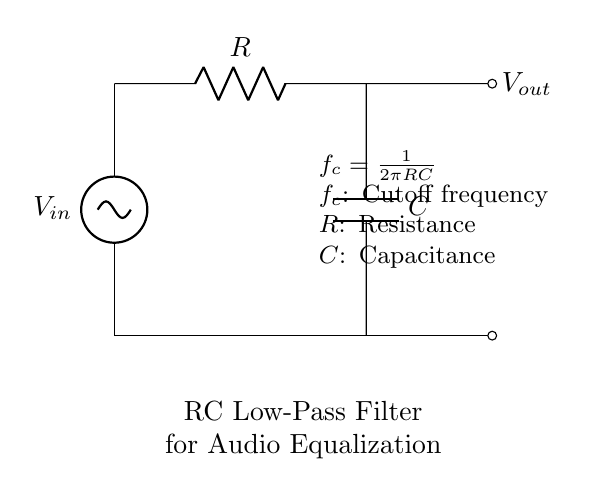What is the input voltage of this circuit? The input voltage is represented by the symbol V_in, which is located at the top of the circuit diagram.
Answer: V_in What components are present in this RC filter? The components in the circuit are a resistor and a capacitor, which are labeled as R and C, respectively.
Answer: Resistor and Capacitor What is the function of this RC circuit? The RC circuit functions as a low-pass filter, indicated by the description provided in the diagram. Low-pass filters allow low-frequency signals to pass while attenuating higher frequencies.
Answer: Low-pass filter What is the cutoff frequency formula for this circuit? The cutoff frequency formula is given as f_c = 1 / (2πRC) in the diagram. This equation describes how the cutoff frequency is determined based on the resistance (R) and capacitance (C) values.
Answer: f_c = 1 / (2πRC) If R is doubled while C remains the same, how does the cutoff frequency change? If R is doubled, the cutoff frequency f_c will decrease because it is inversely proportional to R in the formula f_c = 1 / (2πRC). Thus, increasing R would lead to a lower cutoff frequency. The calculation shows that a higher R leads to a smaller f_c.
Answer: Decreases What happens to the output voltage when the input frequency is much greater than the cutoff frequency? When the input frequency is much greater than the cutoff frequency, the output voltage V_out will be significantly attenuated, approaching zero, as the low-pass filter blocks higher frequencies.
Answer: Approaches zero What is the relationship between resistance and capacitance in this circuit? The relationship is described by the cutoff frequency equation, where both the resistance R and capacitance C affect the filtering characteristics: increasing R or C results in a lower cutoff frequency. This relationship reveals how the two components work together within the filter.
Answer: Inversely related to cutoff frequency 